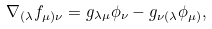Convert formula to latex. <formula><loc_0><loc_0><loc_500><loc_500>\nabla _ { ( \lambda } f _ { \mu ) \nu } = g _ { \lambda \mu } \phi _ { \nu } - g _ { \nu ( \lambda } \phi _ { \mu ) } ,</formula> 